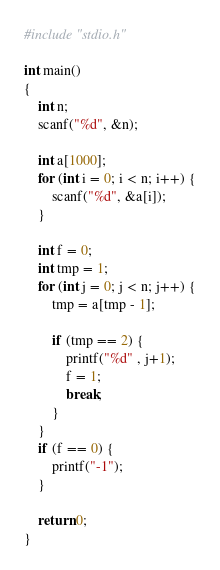Convert code to text. <code><loc_0><loc_0><loc_500><loc_500><_C_>#include "stdio.h"

int main()
{
    int n;
    scanf("%d", &n);

	int a[1000];
	for (int i = 0; i < n; i++) {
		scanf("%d", &a[i]);
	}

	int f = 0;
	int tmp = 1;
	for (int j = 0; j < n; j++) {
		tmp = a[tmp - 1];

		if (tmp == 2) {
			printf("%d" , j+1);
			f = 1;
			break;
		}
	}
	if (f == 0) {
		printf("-1");
	}

    return 0;
}</code> 